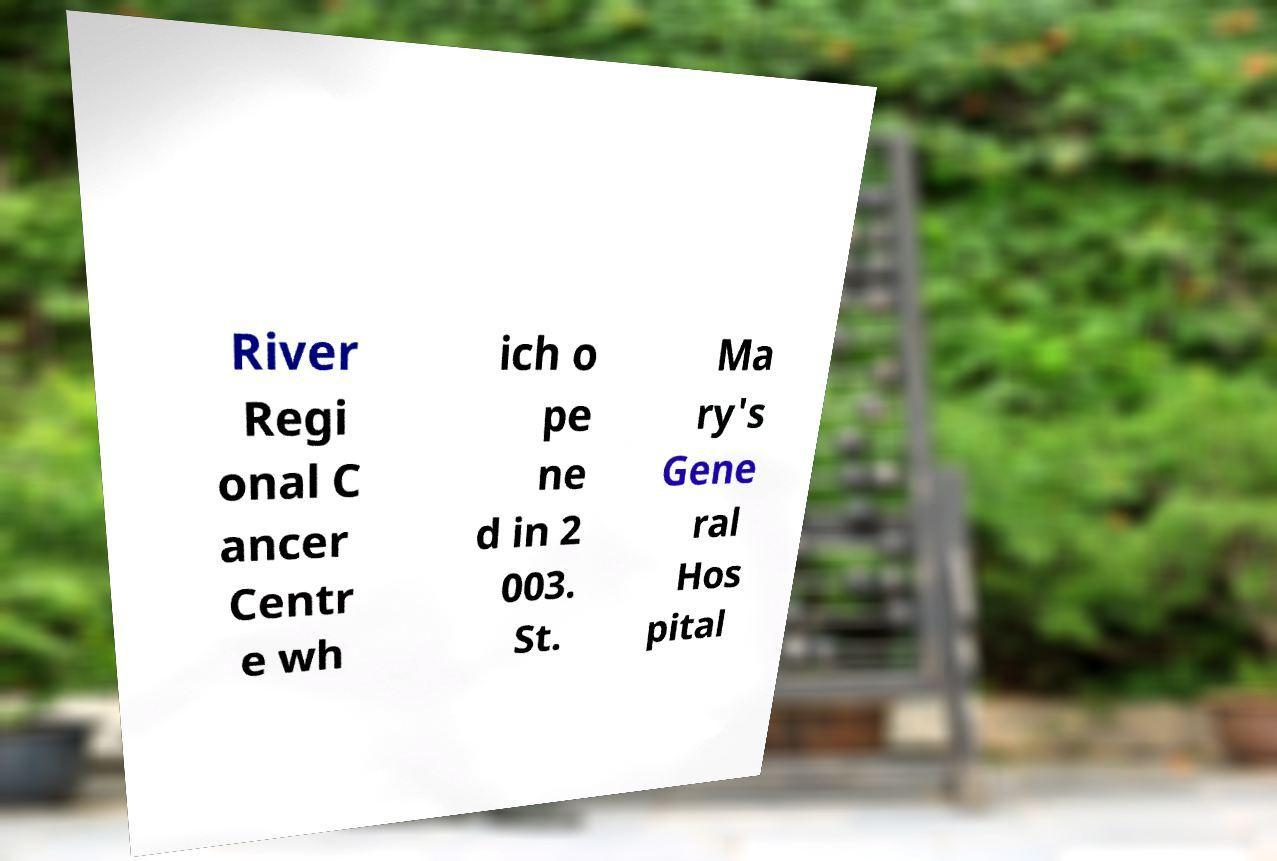Could you extract and type out the text from this image? River Regi onal C ancer Centr e wh ich o pe ne d in 2 003. St. Ma ry's Gene ral Hos pital 